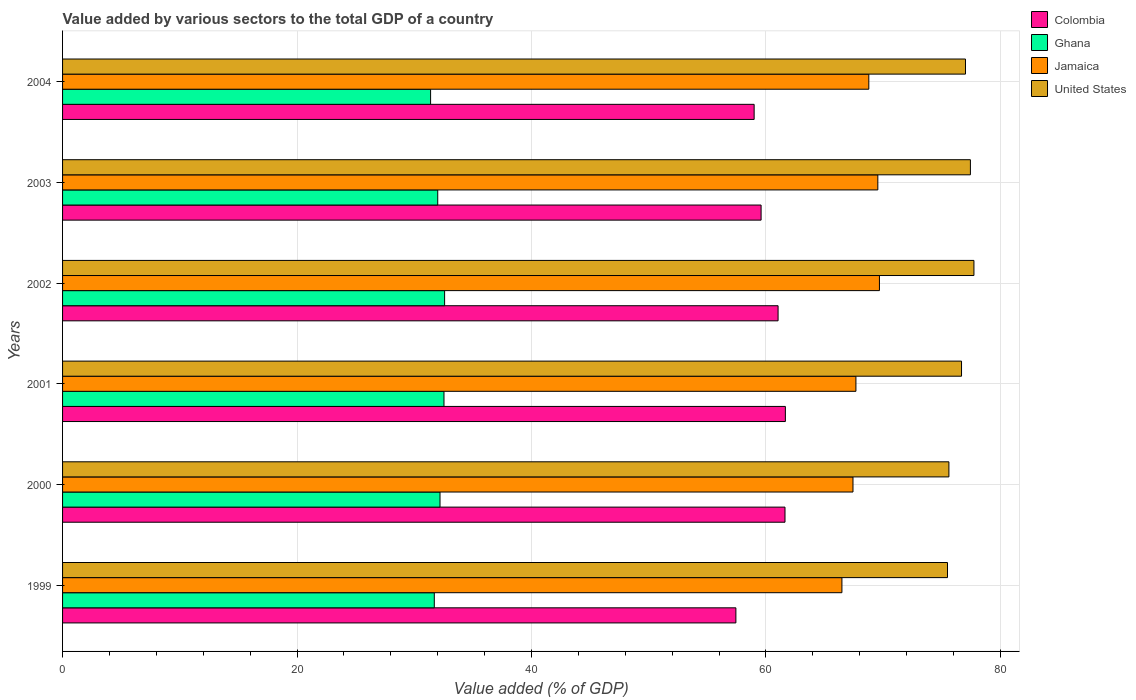How many different coloured bars are there?
Offer a terse response. 4. How many groups of bars are there?
Make the answer very short. 6. Are the number of bars per tick equal to the number of legend labels?
Make the answer very short. Yes. How many bars are there on the 4th tick from the top?
Ensure brevity in your answer.  4. How many bars are there on the 1st tick from the bottom?
Keep it short and to the point. 4. What is the label of the 4th group of bars from the top?
Make the answer very short. 2001. In how many cases, is the number of bars for a given year not equal to the number of legend labels?
Offer a terse response. 0. What is the value added by various sectors to the total GDP in Ghana in 1999?
Ensure brevity in your answer.  31.71. Across all years, what is the maximum value added by various sectors to the total GDP in Colombia?
Make the answer very short. 61.66. Across all years, what is the minimum value added by various sectors to the total GDP in Jamaica?
Ensure brevity in your answer.  66.48. In which year was the value added by various sectors to the total GDP in United States minimum?
Offer a very short reply. 1999. What is the total value added by various sectors to the total GDP in Jamaica in the graph?
Provide a short and direct response. 409.6. What is the difference between the value added by various sectors to the total GDP in Colombia in 2002 and that in 2004?
Keep it short and to the point. 2.04. What is the difference between the value added by various sectors to the total GDP in Jamaica in 2004 and the value added by various sectors to the total GDP in Colombia in 2001?
Your answer should be compact. 7.12. What is the average value added by various sectors to the total GDP in United States per year?
Your response must be concise. 76.67. In the year 2000, what is the difference between the value added by various sectors to the total GDP in Jamaica and value added by various sectors to the total GDP in Colombia?
Offer a terse response. 5.8. In how many years, is the value added by various sectors to the total GDP in Colombia greater than 40 %?
Make the answer very short. 6. What is the ratio of the value added by various sectors to the total GDP in United States in 1999 to that in 2002?
Your answer should be compact. 0.97. Is the value added by various sectors to the total GDP in Ghana in 2002 less than that in 2003?
Give a very brief answer. No. What is the difference between the highest and the second highest value added by various sectors to the total GDP in Colombia?
Your response must be concise. 0.03. What is the difference between the highest and the lowest value added by various sectors to the total GDP in Colombia?
Give a very brief answer. 4.22. What does the 2nd bar from the top in 2002 represents?
Give a very brief answer. Jamaica. What does the 3rd bar from the bottom in 2004 represents?
Offer a terse response. Jamaica. Is it the case that in every year, the sum of the value added by various sectors to the total GDP in Colombia and value added by various sectors to the total GDP in United States is greater than the value added by various sectors to the total GDP in Ghana?
Offer a very short reply. Yes. What is the difference between two consecutive major ticks on the X-axis?
Give a very brief answer. 20. Are the values on the major ticks of X-axis written in scientific E-notation?
Give a very brief answer. No. Does the graph contain any zero values?
Offer a terse response. No. Does the graph contain grids?
Offer a very short reply. Yes. How many legend labels are there?
Your response must be concise. 4. How are the legend labels stacked?
Provide a succinct answer. Vertical. What is the title of the graph?
Offer a terse response. Value added by various sectors to the total GDP of a country. Does "Guatemala" appear as one of the legend labels in the graph?
Make the answer very short. No. What is the label or title of the X-axis?
Your answer should be very brief. Value added (% of GDP). What is the label or title of the Y-axis?
Your answer should be compact. Years. What is the Value added (% of GDP) in Colombia in 1999?
Give a very brief answer. 57.44. What is the Value added (% of GDP) of Ghana in 1999?
Offer a very short reply. 31.71. What is the Value added (% of GDP) in Jamaica in 1999?
Offer a very short reply. 66.48. What is the Value added (% of GDP) of United States in 1999?
Your response must be concise. 75.49. What is the Value added (% of GDP) of Colombia in 2000?
Provide a succinct answer. 61.63. What is the Value added (% of GDP) of Ghana in 2000?
Provide a short and direct response. 32.2. What is the Value added (% of GDP) of Jamaica in 2000?
Ensure brevity in your answer.  67.43. What is the Value added (% of GDP) in United States in 2000?
Ensure brevity in your answer.  75.61. What is the Value added (% of GDP) in Colombia in 2001?
Keep it short and to the point. 61.66. What is the Value added (% of GDP) of Ghana in 2001?
Offer a very short reply. 32.54. What is the Value added (% of GDP) in Jamaica in 2001?
Your answer should be very brief. 67.68. What is the Value added (% of GDP) in United States in 2001?
Provide a succinct answer. 76.69. What is the Value added (% of GDP) in Colombia in 2002?
Give a very brief answer. 61.04. What is the Value added (% of GDP) in Ghana in 2002?
Ensure brevity in your answer.  32.59. What is the Value added (% of GDP) in Jamaica in 2002?
Ensure brevity in your answer.  69.69. What is the Value added (% of GDP) of United States in 2002?
Make the answer very short. 77.75. What is the Value added (% of GDP) in Colombia in 2003?
Provide a short and direct response. 59.59. What is the Value added (% of GDP) in Ghana in 2003?
Provide a succinct answer. 32. What is the Value added (% of GDP) of Jamaica in 2003?
Your response must be concise. 69.55. What is the Value added (% of GDP) in United States in 2003?
Give a very brief answer. 77.45. What is the Value added (% of GDP) of Colombia in 2004?
Ensure brevity in your answer.  59. What is the Value added (% of GDP) of Ghana in 2004?
Make the answer very short. 31.39. What is the Value added (% of GDP) in Jamaica in 2004?
Ensure brevity in your answer.  68.78. What is the Value added (% of GDP) of United States in 2004?
Your answer should be very brief. 77.02. Across all years, what is the maximum Value added (% of GDP) of Colombia?
Your answer should be compact. 61.66. Across all years, what is the maximum Value added (% of GDP) in Ghana?
Ensure brevity in your answer.  32.59. Across all years, what is the maximum Value added (% of GDP) of Jamaica?
Keep it short and to the point. 69.69. Across all years, what is the maximum Value added (% of GDP) of United States?
Provide a short and direct response. 77.75. Across all years, what is the minimum Value added (% of GDP) of Colombia?
Provide a succinct answer. 57.44. Across all years, what is the minimum Value added (% of GDP) of Ghana?
Keep it short and to the point. 31.39. Across all years, what is the minimum Value added (% of GDP) of Jamaica?
Offer a terse response. 66.48. Across all years, what is the minimum Value added (% of GDP) of United States?
Offer a very short reply. 75.49. What is the total Value added (% of GDP) of Colombia in the graph?
Your response must be concise. 360.35. What is the total Value added (% of GDP) of Ghana in the graph?
Give a very brief answer. 192.44. What is the total Value added (% of GDP) of Jamaica in the graph?
Offer a very short reply. 409.6. What is the total Value added (% of GDP) of United States in the graph?
Ensure brevity in your answer.  460.01. What is the difference between the Value added (% of GDP) in Colombia in 1999 and that in 2000?
Ensure brevity in your answer.  -4.19. What is the difference between the Value added (% of GDP) of Ghana in 1999 and that in 2000?
Provide a succinct answer. -0.49. What is the difference between the Value added (% of GDP) of Jamaica in 1999 and that in 2000?
Provide a short and direct response. -0.94. What is the difference between the Value added (% of GDP) of United States in 1999 and that in 2000?
Your answer should be very brief. -0.12. What is the difference between the Value added (% of GDP) of Colombia in 1999 and that in 2001?
Your answer should be very brief. -4.22. What is the difference between the Value added (% of GDP) of Ghana in 1999 and that in 2001?
Make the answer very short. -0.83. What is the difference between the Value added (% of GDP) of Jamaica in 1999 and that in 2001?
Your answer should be very brief. -1.19. What is the difference between the Value added (% of GDP) in United States in 1999 and that in 2001?
Your answer should be compact. -1.2. What is the difference between the Value added (% of GDP) in Colombia in 1999 and that in 2002?
Ensure brevity in your answer.  -3.6. What is the difference between the Value added (% of GDP) of Ghana in 1999 and that in 2002?
Provide a short and direct response. -0.88. What is the difference between the Value added (% of GDP) in Jamaica in 1999 and that in 2002?
Make the answer very short. -3.2. What is the difference between the Value added (% of GDP) of United States in 1999 and that in 2002?
Provide a short and direct response. -2.26. What is the difference between the Value added (% of GDP) in Colombia in 1999 and that in 2003?
Keep it short and to the point. -2.15. What is the difference between the Value added (% of GDP) in Ghana in 1999 and that in 2003?
Give a very brief answer. -0.29. What is the difference between the Value added (% of GDP) in Jamaica in 1999 and that in 2003?
Provide a short and direct response. -3.06. What is the difference between the Value added (% of GDP) of United States in 1999 and that in 2003?
Give a very brief answer. -1.95. What is the difference between the Value added (% of GDP) of Colombia in 1999 and that in 2004?
Your answer should be compact. -1.56. What is the difference between the Value added (% of GDP) in Ghana in 1999 and that in 2004?
Provide a succinct answer. 0.32. What is the difference between the Value added (% of GDP) in Jamaica in 1999 and that in 2004?
Offer a very short reply. -2.29. What is the difference between the Value added (% of GDP) in United States in 1999 and that in 2004?
Offer a terse response. -1.53. What is the difference between the Value added (% of GDP) in Colombia in 2000 and that in 2001?
Keep it short and to the point. -0.03. What is the difference between the Value added (% of GDP) of Ghana in 2000 and that in 2001?
Provide a succinct answer. -0.34. What is the difference between the Value added (% of GDP) of Jamaica in 2000 and that in 2001?
Offer a terse response. -0.25. What is the difference between the Value added (% of GDP) in United States in 2000 and that in 2001?
Ensure brevity in your answer.  -1.08. What is the difference between the Value added (% of GDP) in Colombia in 2000 and that in 2002?
Keep it short and to the point. 0.59. What is the difference between the Value added (% of GDP) of Ghana in 2000 and that in 2002?
Keep it short and to the point. -0.39. What is the difference between the Value added (% of GDP) of Jamaica in 2000 and that in 2002?
Your answer should be very brief. -2.26. What is the difference between the Value added (% of GDP) in United States in 2000 and that in 2002?
Provide a short and direct response. -2.13. What is the difference between the Value added (% of GDP) of Colombia in 2000 and that in 2003?
Make the answer very short. 2.04. What is the difference between the Value added (% of GDP) of Ghana in 2000 and that in 2003?
Your response must be concise. 0.19. What is the difference between the Value added (% of GDP) of Jamaica in 2000 and that in 2003?
Your answer should be compact. -2.12. What is the difference between the Value added (% of GDP) of United States in 2000 and that in 2003?
Make the answer very short. -1.83. What is the difference between the Value added (% of GDP) of Colombia in 2000 and that in 2004?
Provide a succinct answer. 2.63. What is the difference between the Value added (% of GDP) of Ghana in 2000 and that in 2004?
Keep it short and to the point. 0.8. What is the difference between the Value added (% of GDP) of Jamaica in 2000 and that in 2004?
Give a very brief answer. -1.35. What is the difference between the Value added (% of GDP) of United States in 2000 and that in 2004?
Your response must be concise. -1.41. What is the difference between the Value added (% of GDP) in Colombia in 2001 and that in 2002?
Offer a very short reply. 0.62. What is the difference between the Value added (% of GDP) in Ghana in 2001 and that in 2002?
Offer a very short reply. -0.05. What is the difference between the Value added (% of GDP) of Jamaica in 2001 and that in 2002?
Give a very brief answer. -2.01. What is the difference between the Value added (% of GDP) in United States in 2001 and that in 2002?
Provide a succinct answer. -1.06. What is the difference between the Value added (% of GDP) of Colombia in 2001 and that in 2003?
Offer a terse response. 2.07. What is the difference between the Value added (% of GDP) in Ghana in 2001 and that in 2003?
Your answer should be very brief. 0.53. What is the difference between the Value added (% of GDP) of Jamaica in 2001 and that in 2003?
Provide a short and direct response. -1.87. What is the difference between the Value added (% of GDP) of United States in 2001 and that in 2003?
Your answer should be compact. -0.76. What is the difference between the Value added (% of GDP) in Colombia in 2001 and that in 2004?
Your answer should be very brief. 2.66. What is the difference between the Value added (% of GDP) in Ghana in 2001 and that in 2004?
Ensure brevity in your answer.  1.14. What is the difference between the Value added (% of GDP) in Jamaica in 2001 and that in 2004?
Provide a succinct answer. -1.1. What is the difference between the Value added (% of GDP) of United States in 2001 and that in 2004?
Ensure brevity in your answer.  -0.34. What is the difference between the Value added (% of GDP) of Colombia in 2002 and that in 2003?
Provide a short and direct response. 1.45. What is the difference between the Value added (% of GDP) in Ghana in 2002 and that in 2003?
Make the answer very short. 0.59. What is the difference between the Value added (% of GDP) of Jamaica in 2002 and that in 2003?
Provide a short and direct response. 0.14. What is the difference between the Value added (% of GDP) in United States in 2002 and that in 2003?
Ensure brevity in your answer.  0.3. What is the difference between the Value added (% of GDP) in Colombia in 2002 and that in 2004?
Your answer should be very brief. 2.04. What is the difference between the Value added (% of GDP) of Ghana in 2002 and that in 2004?
Keep it short and to the point. 1.2. What is the difference between the Value added (% of GDP) in Jamaica in 2002 and that in 2004?
Ensure brevity in your answer.  0.91. What is the difference between the Value added (% of GDP) of United States in 2002 and that in 2004?
Make the answer very short. 0.72. What is the difference between the Value added (% of GDP) in Colombia in 2003 and that in 2004?
Make the answer very short. 0.59. What is the difference between the Value added (% of GDP) of Ghana in 2003 and that in 2004?
Give a very brief answer. 0.61. What is the difference between the Value added (% of GDP) of Jamaica in 2003 and that in 2004?
Provide a short and direct response. 0.77. What is the difference between the Value added (% of GDP) of United States in 2003 and that in 2004?
Keep it short and to the point. 0.42. What is the difference between the Value added (% of GDP) in Colombia in 1999 and the Value added (% of GDP) in Ghana in 2000?
Offer a very short reply. 25.24. What is the difference between the Value added (% of GDP) in Colombia in 1999 and the Value added (% of GDP) in Jamaica in 2000?
Provide a short and direct response. -9.99. What is the difference between the Value added (% of GDP) of Colombia in 1999 and the Value added (% of GDP) of United States in 2000?
Your answer should be compact. -18.17. What is the difference between the Value added (% of GDP) in Ghana in 1999 and the Value added (% of GDP) in Jamaica in 2000?
Your answer should be very brief. -35.72. What is the difference between the Value added (% of GDP) of Ghana in 1999 and the Value added (% of GDP) of United States in 2000?
Make the answer very short. -43.9. What is the difference between the Value added (% of GDP) in Jamaica in 1999 and the Value added (% of GDP) in United States in 2000?
Make the answer very short. -9.13. What is the difference between the Value added (% of GDP) of Colombia in 1999 and the Value added (% of GDP) of Ghana in 2001?
Offer a very short reply. 24.9. What is the difference between the Value added (% of GDP) in Colombia in 1999 and the Value added (% of GDP) in Jamaica in 2001?
Your answer should be very brief. -10.24. What is the difference between the Value added (% of GDP) of Colombia in 1999 and the Value added (% of GDP) of United States in 2001?
Provide a succinct answer. -19.25. What is the difference between the Value added (% of GDP) in Ghana in 1999 and the Value added (% of GDP) in Jamaica in 2001?
Offer a terse response. -35.97. What is the difference between the Value added (% of GDP) in Ghana in 1999 and the Value added (% of GDP) in United States in 2001?
Provide a short and direct response. -44.98. What is the difference between the Value added (% of GDP) in Jamaica in 1999 and the Value added (% of GDP) in United States in 2001?
Make the answer very short. -10.2. What is the difference between the Value added (% of GDP) in Colombia in 1999 and the Value added (% of GDP) in Ghana in 2002?
Give a very brief answer. 24.85. What is the difference between the Value added (% of GDP) in Colombia in 1999 and the Value added (% of GDP) in Jamaica in 2002?
Your answer should be very brief. -12.25. What is the difference between the Value added (% of GDP) in Colombia in 1999 and the Value added (% of GDP) in United States in 2002?
Your answer should be compact. -20.31. What is the difference between the Value added (% of GDP) in Ghana in 1999 and the Value added (% of GDP) in Jamaica in 2002?
Your answer should be compact. -37.97. What is the difference between the Value added (% of GDP) of Ghana in 1999 and the Value added (% of GDP) of United States in 2002?
Offer a terse response. -46.04. What is the difference between the Value added (% of GDP) in Jamaica in 1999 and the Value added (% of GDP) in United States in 2002?
Keep it short and to the point. -11.26. What is the difference between the Value added (% of GDP) of Colombia in 1999 and the Value added (% of GDP) of Ghana in 2003?
Make the answer very short. 25.44. What is the difference between the Value added (% of GDP) in Colombia in 1999 and the Value added (% of GDP) in Jamaica in 2003?
Your response must be concise. -12.11. What is the difference between the Value added (% of GDP) in Colombia in 1999 and the Value added (% of GDP) in United States in 2003?
Provide a short and direct response. -20.01. What is the difference between the Value added (% of GDP) in Ghana in 1999 and the Value added (% of GDP) in Jamaica in 2003?
Offer a very short reply. -37.84. What is the difference between the Value added (% of GDP) in Ghana in 1999 and the Value added (% of GDP) in United States in 2003?
Provide a short and direct response. -45.73. What is the difference between the Value added (% of GDP) in Jamaica in 1999 and the Value added (% of GDP) in United States in 2003?
Provide a short and direct response. -10.96. What is the difference between the Value added (% of GDP) in Colombia in 1999 and the Value added (% of GDP) in Ghana in 2004?
Keep it short and to the point. 26.04. What is the difference between the Value added (% of GDP) of Colombia in 1999 and the Value added (% of GDP) of Jamaica in 2004?
Your answer should be very brief. -11.34. What is the difference between the Value added (% of GDP) of Colombia in 1999 and the Value added (% of GDP) of United States in 2004?
Make the answer very short. -19.59. What is the difference between the Value added (% of GDP) of Ghana in 1999 and the Value added (% of GDP) of Jamaica in 2004?
Your answer should be very brief. -37.07. What is the difference between the Value added (% of GDP) in Ghana in 1999 and the Value added (% of GDP) in United States in 2004?
Provide a succinct answer. -45.31. What is the difference between the Value added (% of GDP) of Jamaica in 1999 and the Value added (% of GDP) of United States in 2004?
Offer a very short reply. -10.54. What is the difference between the Value added (% of GDP) in Colombia in 2000 and the Value added (% of GDP) in Ghana in 2001?
Make the answer very short. 29.09. What is the difference between the Value added (% of GDP) in Colombia in 2000 and the Value added (% of GDP) in Jamaica in 2001?
Give a very brief answer. -6.05. What is the difference between the Value added (% of GDP) of Colombia in 2000 and the Value added (% of GDP) of United States in 2001?
Keep it short and to the point. -15.06. What is the difference between the Value added (% of GDP) of Ghana in 2000 and the Value added (% of GDP) of Jamaica in 2001?
Your answer should be very brief. -35.48. What is the difference between the Value added (% of GDP) in Ghana in 2000 and the Value added (% of GDP) in United States in 2001?
Your response must be concise. -44.49. What is the difference between the Value added (% of GDP) of Jamaica in 2000 and the Value added (% of GDP) of United States in 2001?
Your response must be concise. -9.26. What is the difference between the Value added (% of GDP) of Colombia in 2000 and the Value added (% of GDP) of Ghana in 2002?
Ensure brevity in your answer.  29.04. What is the difference between the Value added (% of GDP) of Colombia in 2000 and the Value added (% of GDP) of Jamaica in 2002?
Ensure brevity in your answer.  -8.06. What is the difference between the Value added (% of GDP) of Colombia in 2000 and the Value added (% of GDP) of United States in 2002?
Your answer should be compact. -16.12. What is the difference between the Value added (% of GDP) of Ghana in 2000 and the Value added (% of GDP) of Jamaica in 2002?
Your answer should be very brief. -37.49. What is the difference between the Value added (% of GDP) in Ghana in 2000 and the Value added (% of GDP) in United States in 2002?
Offer a terse response. -45.55. What is the difference between the Value added (% of GDP) in Jamaica in 2000 and the Value added (% of GDP) in United States in 2002?
Provide a short and direct response. -10.32. What is the difference between the Value added (% of GDP) in Colombia in 2000 and the Value added (% of GDP) in Ghana in 2003?
Keep it short and to the point. 29.62. What is the difference between the Value added (% of GDP) of Colombia in 2000 and the Value added (% of GDP) of Jamaica in 2003?
Offer a terse response. -7.92. What is the difference between the Value added (% of GDP) of Colombia in 2000 and the Value added (% of GDP) of United States in 2003?
Provide a short and direct response. -15.82. What is the difference between the Value added (% of GDP) in Ghana in 2000 and the Value added (% of GDP) in Jamaica in 2003?
Provide a succinct answer. -37.35. What is the difference between the Value added (% of GDP) of Ghana in 2000 and the Value added (% of GDP) of United States in 2003?
Your answer should be very brief. -45.25. What is the difference between the Value added (% of GDP) in Jamaica in 2000 and the Value added (% of GDP) in United States in 2003?
Your answer should be compact. -10.02. What is the difference between the Value added (% of GDP) of Colombia in 2000 and the Value added (% of GDP) of Ghana in 2004?
Keep it short and to the point. 30.23. What is the difference between the Value added (% of GDP) in Colombia in 2000 and the Value added (% of GDP) in Jamaica in 2004?
Keep it short and to the point. -7.15. What is the difference between the Value added (% of GDP) in Colombia in 2000 and the Value added (% of GDP) in United States in 2004?
Your response must be concise. -15.4. What is the difference between the Value added (% of GDP) of Ghana in 2000 and the Value added (% of GDP) of Jamaica in 2004?
Your answer should be compact. -36.58. What is the difference between the Value added (% of GDP) in Ghana in 2000 and the Value added (% of GDP) in United States in 2004?
Give a very brief answer. -44.83. What is the difference between the Value added (% of GDP) in Jamaica in 2000 and the Value added (% of GDP) in United States in 2004?
Provide a short and direct response. -9.6. What is the difference between the Value added (% of GDP) in Colombia in 2001 and the Value added (% of GDP) in Ghana in 2002?
Offer a very short reply. 29.07. What is the difference between the Value added (% of GDP) in Colombia in 2001 and the Value added (% of GDP) in Jamaica in 2002?
Provide a succinct answer. -8.02. What is the difference between the Value added (% of GDP) of Colombia in 2001 and the Value added (% of GDP) of United States in 2002?
Ensure brevity in your answer.  -16.09. What is the difference between the Value added (% of GDP) in Ghana in 2001 and the Value added (% of GDP) in Jamaica in 2002?
Ensure brevity in your answer.  -37.15. What is the difference between the Value added (% of GDP) in Ghana in 2001 and the Value added (% of GDP) in United States in 2002?
Make the answer very short. -45.21. What is the difference between the Value added (% of GDP) in Jamaica in 2001 and the Value added (% of GDP) in United States in 2002?
Keep it short and to the point. -10.07. What is the difference between the Value added (% of GDP) of Colombia in 2001 and the Value added (% of GDP) of Ghana in 2003?
Offer a terse response. 29.66. What is the difference between the Value added (% of GDP) in Colombia in 2001 and the Value added (% of GDP) in Jamaica in 2003?
Keep it short and to the point. -7.89. What is the difference between the Value added (% of GDP) in Colombia in 2001 and the Value added (% of GDP) in United States in 2003?
Offer a terse response. -15.78. What is the difference between the Value added (% of GDP) in Ghana in 2001 and the Value added (% of GDP) in Jamaica in 2003?
Make the answer very short. -37.01. What is the difference between the Value added (% of GDP) of Ghana in 2001 and the Value added (% of GDP) of United States in 2003?
Provide a short and direct response. -44.91. What is the difference between the Value added (% of GDP) in Jamaica in 2001 and the Value added (% of GDP) in United States in 2003?
Ensure brevity in your answer.  -9.77. What is the difference between the Value added (% of GDP) of Colombia in 2001 and the Value added (% of GDP) of Ghana in 2004?
Ensure brevity in your answer.  30.27. What is the difference between the Value added (% of GDP) of Colombia in 2001 and the Value added (% of GDP) of Jamaica in 2004?
Your response must be concise. -7.12. What is the difference between the Value added (% of GDP) of Colombia in 2001 and the Value added (% of GDP) of United States in 2004?
Provide a short and direct response. -15.36. What is the difference between the Value added (% of GDP) of Ghana in 2001 and the Value added (% of GDP) of Jamaica in 2004?
Provide a short and direct response. -36.24. What is the difference between the Value added (% of GDP) in Ghana in 2001 and the Value added (% of GDP) in United States in 2004?
Your response must be concise. -44.49. What is the difference between the Value added (% of GDP) in Jamaica in 2001 and the Value added (% of GDP) in United States in 2004?
Your answer should be compact. -9.35. What is the difference between the Value added (% of GDP) in Colombia in 2002 and the Value added (% of GDP) in Ghana in 2003?
Your answer should be compact. 29.03. What is the difference between the Value added (% of GDP) of Colombia in 2002 and the Value added (% of GDP) of Jamaica in 2003?
Ensure brevity in your answer.  -8.51. What is the difference between the Value added (% of GDP) of Colombia in 2002 and the Value added (% of GDP) of United States in 2003?
Ensure brevity in your answer.  -16.41. What is the difference between the Value added (% of GDP) in Ghana in 2002 and the Value added (% of GDP) in Jamaica in 2003?
Your answer should be compact. -36.96. What is the difference between the Value added (% of GDP) of Ghana in 2002 and the Value added (% of GDP) of United States in 2003?
Provide a succinct answer. -44.85. What is the difference between the Value added (% of GDP) in Jamaica in 2002 and the Value added (% of GDP) in United States in 2003?
Offer a terse response. -7.76. What is the difference between the Value added (% of GDP) of Colombia in 2002 and the Value added (% of GDP) of Ghana in 2004?
Provide a succinct answer. 29.64. What is the difference between the Value added (% of GDP) in Colombia in 2002 and the Value added (% of GDP) in Jamaica in 2004?
Your answer should be compact. -7.74. What is the difference between the Value added (% of GDP) of Colombia in 2002 and the Value added (% of GDP) of United States in 2004?
Keep it short and to the point. -15.99. What is the difference between the Value added (% of GDP) of Ghana in 2002 and the Value added (% of GDP) of Jamaica in 2004?
Offer a very short reply. -36.19. What is the difference between the Value added (% of GDP) of Ghana in 2002 and the Value added (% of GDP) of United States in 2004?
Keep it short and to the point. -44.43. What is the difference between the Value added (% of GDP) of Jamaica in 2002 and the Value added (% of GDP) of United States in 2004?
Provide a succinct answer. -7.34. What is the difference between the Value added (% of GDP) of Colombia in 2003 and the Value added (% of GDP) of Ghana in 2004?
Make the answer very short. 28.19. What is the difference between the Value added (% of GDP) in Colombia in 2003 and the Value added (% of GDP) in Jamaica in 2004?
Offer a terse response. -9.19. What is the difference between the Value added (% of GDP) of Colombia in 2003 and the Value added (% of GDP) of United States in 2004?
Your answer should be compact. -17.44. What is the difference between the Value added (% of GDP) of Ghana in 2003 and the Value added (% of GDP) of Jamaica in 2004?
Provide a short and direct response. -36.77. What is the difference between the Value added (% of GDP) in Ghana in 2003 and the Value added (% of GDP) in United States in 2004?
Give a very brief answer. -45.02. What is the difference between the Value added (% of GDP) of Jamaica in 2003 and the Value added (% of GDP) of United States in 2004?
Keep it short and to the point. -7.48. What is the average Value added (% of GDP) of Colombia per year?
Your answer should be very brief. 60.06. What is the average Value added (% of GDP) in Ghana per year?
Offer a terse response. 32.07. What is the average Value added (% of GDP) of Jamaica per year?
Give a very brief answer. 68.27. What is the average Value added (% of GDP) in United States per year?
Make the answer very short. 76.67. In the year 1999, what is the difference between the Value added (% of GDP) in Colombia and Value added (% of GDP) in Ghana?
Ensure brevity in your answer.  25.73. In the year 1999, what is the difference between the Value added (% of GDP) of Colombia and Value added (% of GDP) of Jamaica?
Your response must be concise. -9.04. In the year 1999, what is the difference between the Value added (% of GDP) of Colombia and Value added (% of GDP) of United States?
Keep it short and to the point. -18.05. In the year 1999, what is the difference between the Value added (% of GDP) of Ghana and Value added (% of GDP) of Jamaica?
Ensure brevity in your answer.  -34.77. In the year 1999, what is the difference between the Value added (% of GDP) in Ghana and Value added (% of GDP) in United States?
Make the answer very short. -43.78. In the year 1999, what is the difference between the Value added (% of GDP) in Jamaica and Value added (% of GDP) in United States?
Offer a terse response. -9.01. In the year 2000, what is the difference between the Value added (% of GDP) in Colombia and Value added (% of GDP) in Ghana?
Your answer should be compact. 29.43. In the year 2000, what is the difference between the Value added (% of GDP) in Colombia and Value added (% of GDP) in Jamaica?
Your answer should be compact. -5.8. In the year 2000, what is the difference between the Value added (% of GDP) of Colombia and Value added (% of GDP) of United States?
Provide a succinct answer. -13.98. In the year 2000, what is the difference between the Value added (% of GDP) of Ghana and Value added (% of GDP) of Jamaica?
Give a very brief answer. -35.23. In the year 2000, what is the difference between the Value added (% of GDP) in Ghana and Value added (% of GDP) in United States?
Keep it short and to the point. -43.41. In the year 2000, what is the difference between the Value added (% of GDP) of Jamaica and Value added (% of GDP) of United States?
Ensure brevity in your answer.  -8.18. In the year 2001, what is the difference between the Value added (% of GDP) of Colombia and Value added (% of GDP) of Ghana?
Provide a succinct answer. 29.12. In the year 2001, what is the difference between the Value added (% of GDP) of Colombia and Value added (% of GDP) of Jamaica?
Provide a succinct answer. -6.02. In the year 2001, what is the difference between the Value added (% of GDP) in Colombia and Value added (% of GDP) in United States?
Your answer should be very brief. -15.03. In the year 2001, what is the difference between the Value added (% of GDP) in Ghana and Value added (% of GDP) in Jamaica?
Give a very brief answer. -35.14. In the year 2001, what is the difference between the Value added (% of GDP) in Ghana and Value added (% of GDP) in United States?
Your response must be concise. -44.15. In the year 2001, what is the difference between the Value added (% of GDP) in Jamaica and Value added (% of GDP) in United States?
Keep it short and to the point. -9.01. In the year 2002, what is the difference between the Value added (% of GDP) in Colombia and Value added (% of GDP) in Ghana?
Keep it short and to the point. 28.45. In the year 2002, what is the difference between the Value added (% of GDP) in Colombia and Value added (% of GDP) in Jamaica?
Offer a very short reply. -8.65. In the year 2002, what is the difference between the Value added (% of GDP) in Colombia and Value added (% of GDP) in United States?
Make the answer very short. -16.71. In the year 2002, what is the difference between the Value added (% of GDP) of Ghana and Value added (% of GDP) of Jamaica?
Offer a terse response. -37.09. In the year 2002, what is the difference between the Value added (% of GDP) in Ghana and Value added (% of GDP) in United States?
Make the answer very short. -45.16. In the year 2002, what is the difference between the Value added (% of GDP) in Jamaica and Value added (% of GDP) in United States?
Offer a terse response. -8.06. In the year 2003, what is the difference between the Value added (% of GDP) of Colombia and Value added (% of GDP) of Ghana?
Your answer should be very brief. 27.59. In the year 2003, what is the difference between the Value added (% of GDP) of Colombia and Value added (% of GDP) of Jamaica?
Offer a very short reply. -9.96. In the year 2003, what is the difference between the Value added (% of GDP) of Colombia and Value added (% of GDP) of United States?
Your answer should be compact. -17.86. In the year 2003, what is the difference between the Value added (% of GDP) in Ghana and Value added (% of GDP) in Jamaica?
Your response must be concise. -37.54. In the year 2003, what is the difference between the Value added (% of GDP) of Ghana and Value added (% of GDP) of United States?
Your answer should be very brief. -45.44. In the year 2003, what is the difference between the Value added (% of GDP) in Jamaica and Value added (% of GDP) in United States?
Give a very brief answer. -7.9. In the year 2004, what is the difference between the Value added (% of GDP) in Colombia and Value added (% of GDP) in Ghana?
Keep it short and to the point. 27.6. In the year 2004, what is the difference between the Value added (% of GDP) of Colombia and Value added (% of GDP) of Jamaica?
Offer a very short reply. -9.78. In the year 2004, what is the difference between the Value added (% of GDP) of Colombia and Value added (% of GDP) of United States?
Provide a short and direct response. -18.03. In the year 2004, what is the difference between the Value added (% of GDP) of Ghana and Value added (% of GDP) of Jamaica?
Offer a terse response. -37.38. In the year 2004, what is the difference between the Value added (% of GDP) of Ghana and Value added (% of GDP) of United States?
Give a very brief answer. -45.63. In the year 2004, what is the difference between the Value added (% of GDP) in Jamaica and Value added (% of GDP) in United States?
Ensure brevity in your answer.  -8.25. What is the ratio of the Value added (% of GDP) in Colombia in 1999 to that in 2000?
Your answer should be compact. 0.93. What is the ratio of the Value added (% of GDP) of Ghana in 1999 to that in 2000?
Provide a succinct answer. 0.98. What is the ratio of the Value added (% of GDP) of Jamaica in 1999 to that in 2000?
Provide a short and direct response. 0.99. What is the ratio of the Value added (% of GDP) of Colombia in 1999 to that in 2001?
Ensure brevity in your answer.  0.93. What is the ratio of the Value added (% of GDP) in Ghana in 1999 to that in 2001?
Your answer should be very brief. 0.97. What is the ratio of the Value added (% of GDP) in Jamaica in 1999 to that in 2001?
Provide a short and direct response. 0.98. What is the ratio of the Value added (% of GDP) in United States in 1999 to that in 2001?
Make the answer very short. 0.98. What is the ratio of the Value added (% of GDP) of Colombia in 1999 to that in 2002?
Your response must be concise. 0.94. What is the ratio of the Value added (% of GDP) of Ghana in 1999 to that in 2002?
Offer a terse response. 0.97. What is the ratio of the Value added (% of GDP) of Jamaica in 1999 to that in 2002?
Your answer should be very brief. 0.95. What is the ratio of the Value added (% of GDP) in Colombia in 1999 to that in 2003?
Give a very brief answer. 0.96. What is the ratio of the Value added (% of GDP) in Ghana in 1999 to that in 2003?
Provide a short and direct response. 0.99. What is the ratio of the Value added (% of GDP) of Jamaica in 1999 to that in 2003?
Offer a very short reply. 0.96. What is the ratio of the Value added (% of GDP) in United States in 1999 to that in 2003?
Ensure brevity in your answer.  0.97. What is the ratio of the Value added (% of GDP) in Colombia in 1999 to that in 2004?
Keep it short and to the point. 0.97. What is the ratio of the Value added (% of GDP) in Jamaica in 1999 to that in 2004?
Keep it short and to the point. 0.97. What is the ratio of the Value added (% of GDP) of United States in 1999 to that in 2004?
Offer a very short reply. 0.98. What is the ratio of the Value added (% of GDP) in Ghana in 2000 to that in 2001?
Ensure brevity in your answer.  0.99. What is the ratio of the Value added (% of GDP) in Jamaica in 2000 to that in 2001?
Provide a succinct answer. 1. What is the ratio of the Value added (% of GDP) in Colombia in 2000 to that in 2002?
Your response must be concise. 1.01. What is the ratio of the Value added (% of GDP) of Ghana in 2000 to that in 2002?
Provide a succinct answer. 0.99. What is the ratio of the Value added (% of GDP) of Jamaica in 2000 to that in 2002?
Provide a succinct answer. 0.97. What is the ratio of the Value added (% of GDP) in United States in 2000 to that in 2002?
Your answer should be compact. 0.97. What is the ratio of the Value added (% of GDP) in Colombia in 2000 to that in 2003?
Make the answer very short. 1.03. What is the ratio of the Value added (% of GDP) in Ghana in 2000 to that in 2003?
Offer a terse response. 1.01. What is the ratio of the Value added (% of GDP) of Jamaica in 2000 to that in 2003?
Give a very brief answer. 0.97. What is the ratio of the Value added (% of GDP) in United States in 2000 to that in 2003?
Your answer should be very brief. 0.98. What is the ratio of the Value added (% of GDP) of Colombia in 2000 to that in 2004?
Ensure brevity in your answer.  1.04. What is the ratio of the Value added (% of GDP) in Ghana in 2000 to that in 2004?
Provide a succinct answer. 1.03. What is the ratio of the Value added (% of GDP) of Jamaica in 2000 to that in 2004?
Your response must be concise. 0.98. What is the ratio of the Value added (% of GDP) of United States in 2000 to that in 2004?
Give a very brief answer. 0.98. What is the ratio of the Value added (% of GDP) of Colombia in 2001 to that in 2002?
Offer a very short reply. 1.01. What is the ratio of the Value added (% of GDP) of Ghana in 2001 to that in 2002?
Your response must be concise. 1. What is the ratio of the Value added (% of GDP) in Jamaica in 2001 to that in 2002?
Make the answer very short. 0.97. What is the ratio of the Value added (% of GDP) of United States in 2001 to that in 2002?
Ensure brevity in your answer.  0.99. What is the ratio of the Value added (% of GDP) in Colombia in 2001 to that in 2003?
Offer a very short reply. 1.03. What is the ratio of the Value added (% of GDP) in Ghana in 2001 to that in 2003?
Your response must be concise. 1.02. What is the ratio of the Value added (% of GDP) in Jamaica in 2001 to that in 2003?
Your response must be concise. 0.97. What is the ratio of the Value added (% of GDP) in United States in 2001 to that in 2003?
Ensure brevity in your answer.  0.99. What is the ratio of the Value added (% of GDP) in Colombia in 2001 to that in 2004?
Offer a terse response. 1.05. What is the ratio of the Value added (% of GDP) of Ghana in 2001 to that in 2004?
Provide a short and direct response. 1.04. What is the ratio of the Value added (% of GDP) of Colombia in 2002 to that in 2003?
Your response must be concise. 1.02. What is the ratio of the Value added (% of GDP) in Ghana in 2002 to that in 2003?
Provide a short and direct response. 1.02. What is the ratio of the Value added (% of GDP) of Jamaica in 2002 to that in 2003?
Your answer should be compact. 1. What is the ratio of the Value added (% of GDP) of Colombia in 2002 to that in 2004?
Your answer should be compact. 1.03. What is the ratio of the Value added (% of GDP) in Ghana in 2002 to that in 2004?
Give a very brief answer. 1.04. What is the ratio of the Value added (% of GDP) of Jamaica in 2002 to that in 2004?
Your response must be concise. 1.01. What is the ratio of the Value added (% of GDP) in United States in 2002 to that in 2004?
Provide a succinct answer. 1.01. What is the ratio of the Value added (% of GDP) of Ghana in 2003 to that in 2004?
Make the answer very short. 1.02. What is the ratio of the Value added (% of GDP) in Jamaica in 2003 to that in 2004?
Your answer should be compact. 1.01. What is the difference between the highest and the second highest Value added (% of GDP) of Colombia?
Provide a short and direct response. 0.03. What is the difference between the highest and the second highest Value added (% of GDP) of Ghana?
Give a very brief answer. 0.05. What is the difference between the highest and the second highest Value added (% of GDP) in Jamaica?
Your answer should be very brief. 0.14. What is the difference between the highest and the second highest Value added (% of GDP) of United States?
Ensure brevity in your answer.  0.3. What is the difference between the highest and the lowest Value added (% of GDP) of Colombia?
Your response must be concise. 4.22. What is the difference between the highest and the lowest Value added (% of GDP) in Ghana?
Keep it short and to the point. 1.2. What is the difference between the highest and the lowest Value added (% of GDP) in Jamaica?
Give a very brief answer. 3.2. What is the difference between the highest and the lowest Value added (% of GDP) of United States?
Provide a succinct answer. 2.26. 